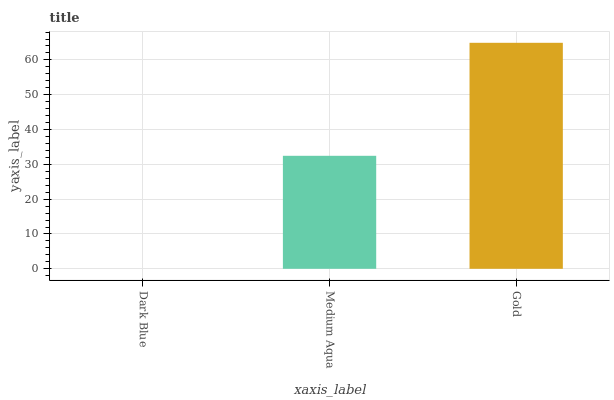Is Dark Blue the minimum?
Answer yes or no. Yes. Is Gold the maximum?
Answer yes or no. Yes. Is Medium Aqua the minimum?
Answer yes or no. No. Is Medium Aqua the maximum?
Answer yes or no. No. Is Medium Aqua greater than Dark Blue?
Answer yes or no. Yes. Is Dark Blue less than Medium Aqua?
Answer yes or no. Yes. Is Dark Blue greater than Medium Aqua?
Answer yes or no. No. Is Medium Aqua less than Dark Blue?
Answer yes or no. No. Is Medium Aqua the high median?
Answer yes or no. Yes. Is Medium Aqua the low median?
Answer yes or no. Yes. Is Gold the high median?
Answer yes or no. No. Is Dark Blue the low median?
Answer yes or no. No. 